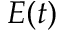Convert formula to latex. <formula><loc_0><loc_0><loc_500><loc_500>E ( t )</formula> 